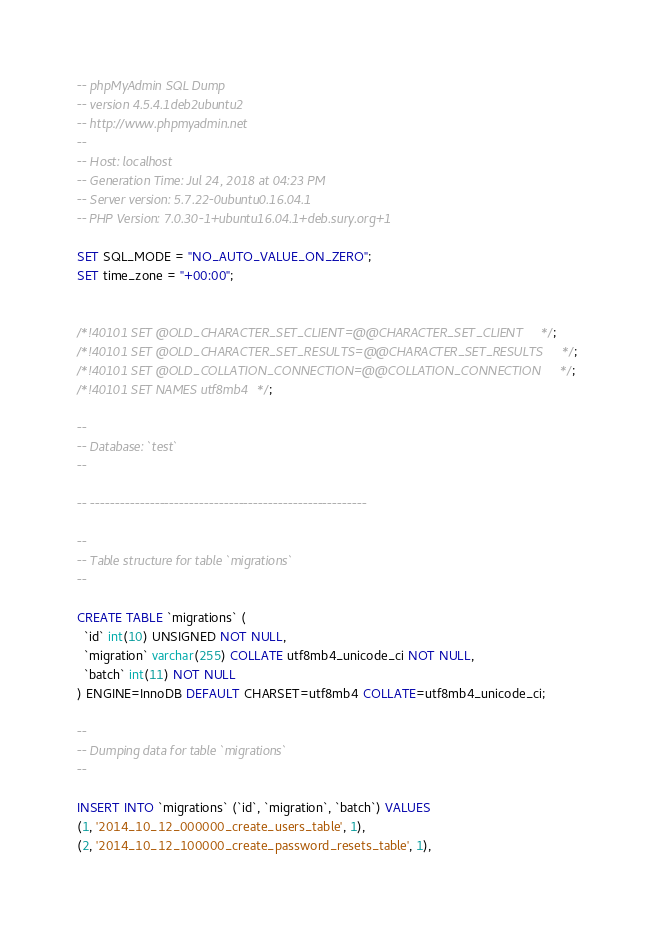Convert code to text. <code><loc_0><loc_0><loc_500><loc_500><_SQL_>-- phpMyAdmin SQL Dump
-- version 4.5.4.1deb2ubuntu2
-- http://www.phpmyadmin.net
--
-- Host: localhost
-- Generation Time: Jul 24, 2018 at 04:23 PM
-- Server version: 5.7.22-0ubuntu0.16.04.1
-- PHP Version: 7.0.30-1+ubuntu16.04.1+deb.sury.org+1

SET SQL_MODE = "NO_AUTO_VALUE_ON_ZERO";
SET time_zone = "+00:00";


/*!40101 SET @OLD_CHARACTER_SET_CLIENT=@@CHARACTER_SET_CLIENT */;
/*!40101 SET @OLD_CHARACTER_SET_RESULTS=@@CHARACTER_SET_RESULTS */;
/*!40101 SET @OLD_COLLATION_CONNECTION=@@COLLATION_CONNECTION */;
/*!40101 SET NAMES utf8mb4 */;

--
-- Database: `test`
--

-- --------------------------------------------------------

--
-- Table structure for table `migrations`
--

CREATE TABLE `migrations` (
  `id` int(10) UNSIGNED NOT NULL,
  `migration` varchar(255) COLLATE utf8mb4_unicode_ci NOT NULL,
  `batch` int(11) NOT NULL
) ENGINE=InnoDB DEFAULT CHARSET=utf8mb4 COLLATE=utf8mb4_unicode_ci;

--
-- Dumping data for table `migrations`
--

INSERT INTO `migrations` (`id`, `migration`, `batch`) VALUES
(1, '2014_10_12_000000_create_users_table', 1),
(2, '2014_10_12_100000_create_password_resets_table', 1),</code> 